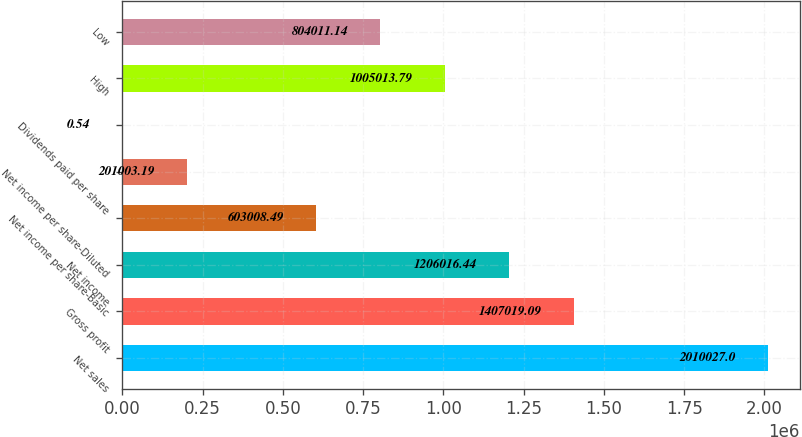Convert chart. <chart><loc_0><loc_0><loc_500><loc_500><bar_chart><fcel>Net sales<fcel>Gross profit<fcel>Net income<fcel>Net income per share-Basic<fcel>Net income per share-Diluted<fcel>Dividends paid per share<fcel>High<fcel>Low<nl><fcel>2.01003e+06<fcel>1.40702e+06<fcel>1.20602e+06<fcel>603008<fcel>201003<fcel>0.54<fcel>1.00501e+06<fcel>804011<nl></chart> 